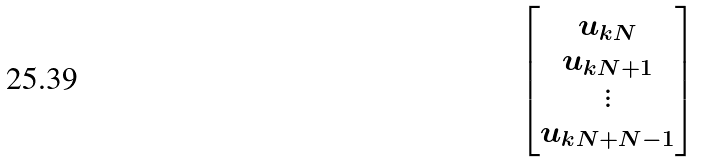Convert formula to latex. <formula><loc_0><loc_0><loc_500><loc_500>\begin{bmatrix} u _ { k N } \\ u _ { k N + 1 } \\ \vdots \\ u _ { k N + N - 1 } \end{bmatrix}</formula> 